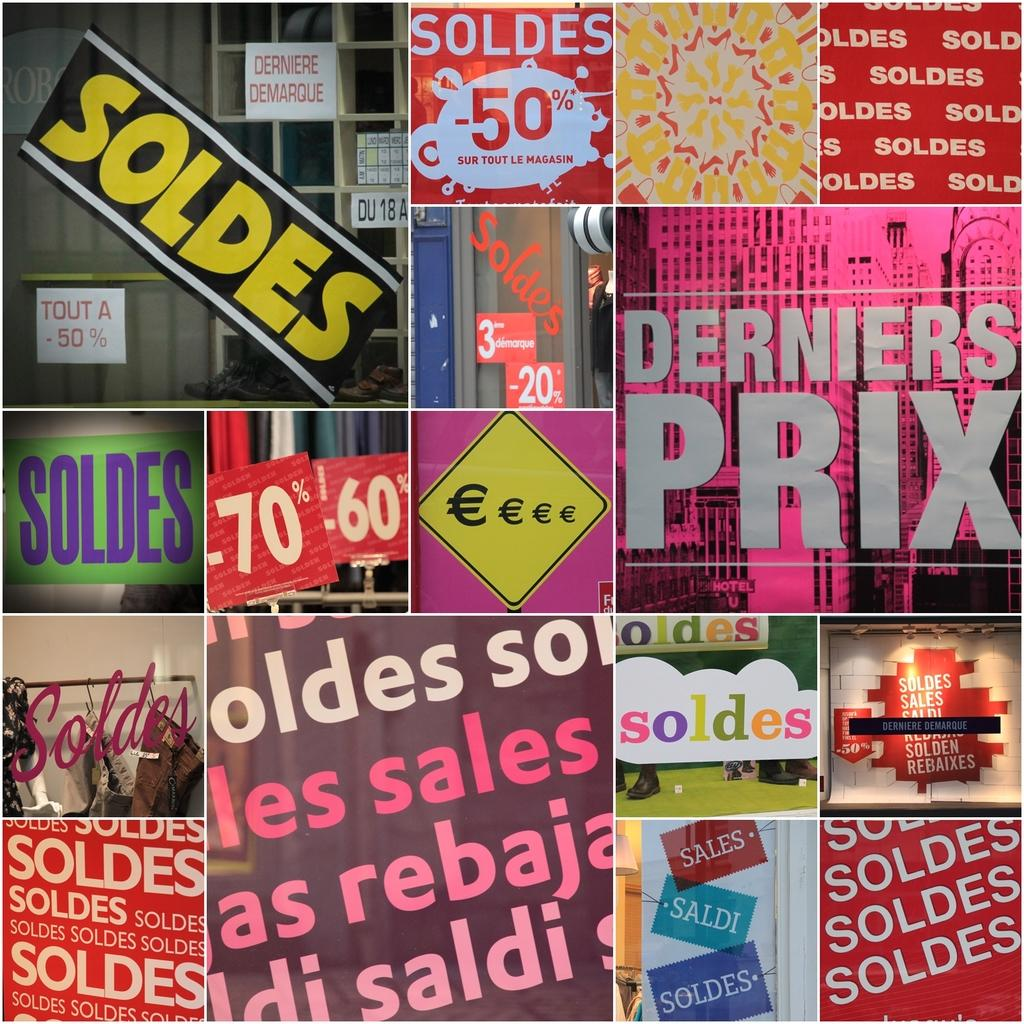<image>
Create a compact narrative representing the image presented. An organized collage of pictures with most containing the word Soldes. 